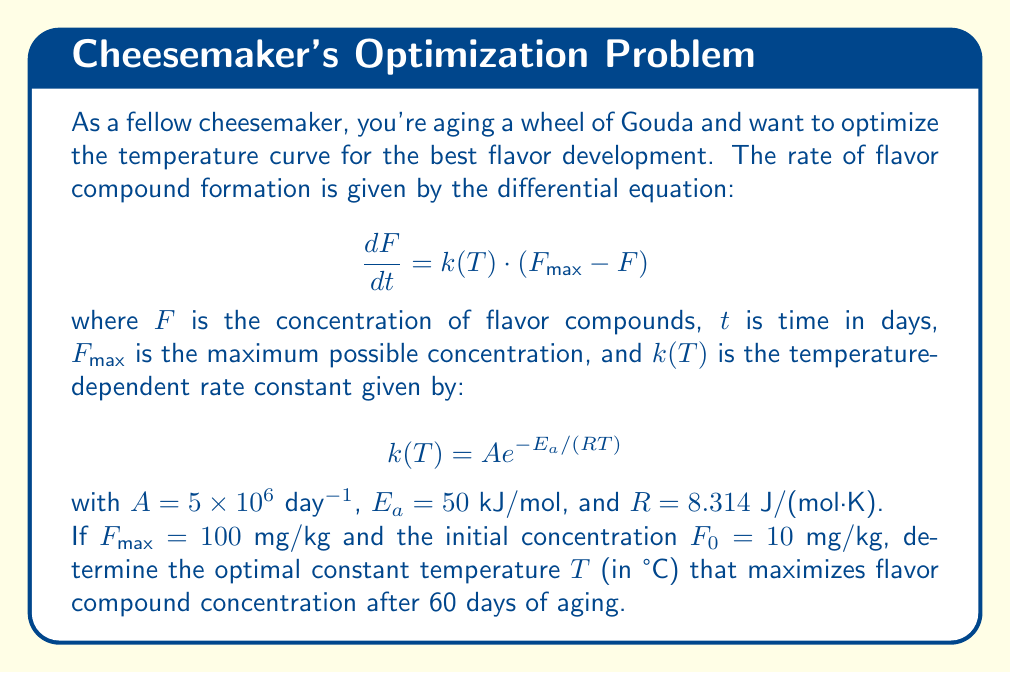Could you help me with this problem? Let's approach this step-by-step:

1) First, we need to solve the differential equation. It's a first-order linear ODE:

   $$\frac{dF}{dt} = k(T) \cdot (F_{max} - F)$$

2) The solution to this equation is:

   $$F(t) = F_{max} - (F_{max} - F_0)e^{-k(T)t}$$

3) We want to maximize $F(60)$, which is equivalent to maximizing $k(T)$:

   $$F(60) = 100 - 90e^{-60k(T)}$$

4) Now, let's focus on $k(T)$:

   $$k(T) = 5 \times 10^6 \exp\left(-\frac{50000}{8.314T}\right)$$

5) To find the maximum, we need to differentiate $k(T)$ with respect to $T$ and set it to zero:

   $$\frac{dk}{dT} = 5 \times 10^6 \cdot \frac{50000}{8.314T^2} \exp\left(-\frac{50000}{8.314T}\right) = 0$$

6) This equation is always positive for positive $T$, meaning $k(T)$ is always increasing with $T$. Therefore, the maximum $k(T)$ occurs at the highest allowable temperature.

7) For cheese aging, we typically don't want to exceed room temperature. Let's assume a maximum of 25°C (298.15 K).

8) At this temperature:

   $$k(298.15) = 5 \times 10^6 \exp\left(-\frac{50000}{8.314 \cdot 298.15}\right) \approx 0.1815$$ day$^{-1}$

9) Therefore, the optimal constant temperature for maximizing flavor compound concentration after 60 days is 25°C.
Answer: 25°C 